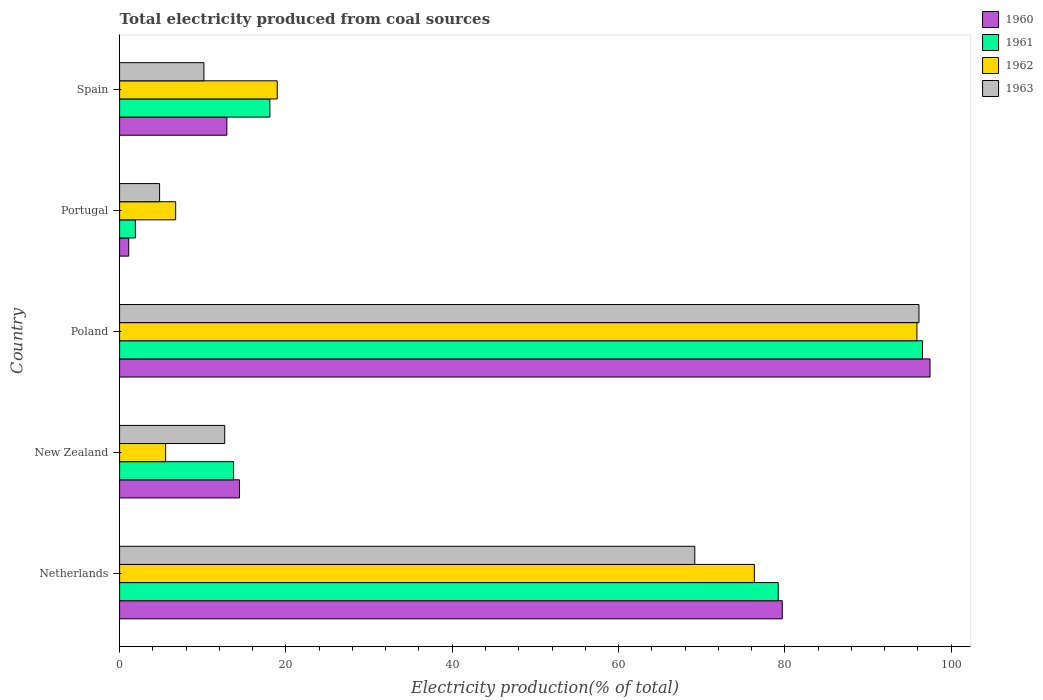How many different coloured bars are there?
Your response must be concise. 4. Are the number of bars per tick equal to the number of legend labels?
Provide a succinct answer. Yes. How many bars are there on the 5th tick from the bottom?
Provide a succinct answer. 4. What is the label of the 5th group of bars from the top?
Offer a terse response. Netherlands. What is the total electricity produced in 1963 in Poland?
Ensure brevity in your answer.  96.13. Across all countries, what is the maximum total electricity produced in 1961?
Your response must be concise. 96.56. Across all countries, what is the minimum total electricity produced in 1960?
Make the answer very short. 1.1. In which country was the total electricity produced in 1961 minimum?
Give a very brief answer. Portugal. What is the total total electricity produced in 1963 in the graph?
Offer a very short reply. 192.89. What is the difference between the total electricity produced in 1960 in Netherlands and that in Portugal?
Your answer should be compact. 78.59. What is the difference between the total electricity produced in 1960 in Portugal and the total electricity produced in 1961 in Spain?
Your answer should be compact. -16.97. What is the average total electricity produced in 1960 per country?
Provide a succinct answer. 41.11. What is the difference between the total electricity produced in 1963 and total electricity produced in 1960 in Poland?
Provide a succinct answer. -1.33. What is the ratio of the total electricity produced in 1961 in Portugal to that in Spain?
Offer a very short reply. 0.1. Is the total electricity produced in 1960 in Netherlands less than that in Spain?
Offer a very short reply. No. What is the difference between the highest and the second highest total electricity produced in 1961?
Your answer should be compact. 17.35. What is the difference between the highest and the lowest total electricity produced in 1960?
Provide a succinct answer. 96.36. What does the 2nd bar from the top in Portugal represents?
Make the answer very short. 1962. What does the 4th bar from the bottom in Spain represents?
Provide a short and direct response. 1963. Are all the bars in the graph horizontal?
Offer a terse response. Yes. How many countries are there in the graph?
Offer a terse response. 5. Does the graph contain grids?
Give a very brief answer. No. How many legend labels are there?
Keep it short and to the point. 4. How are the legend labels stacked?
Offer a terse response. Vertical. What is the title of the graph?
Provide a short and direct response. Total electricity produced from coal sources. What is the label or title of the X-axis?
Ensure brevity in your answer.  Electricity production(% of total). What is the Electricity production(% of total) of 1960 in Netherlands?
Give a very brief answer. 79.69. What is the Electricity production(% of total) of 1961 in Netherlands?
Ensure brevity in your answer.  79.2. What is the Electricity production(% of total) in 1962 in Netherlands?
Offer a very short reply. 76.33. What is the Electricity production(% of total) of 1963 in Netherlands?
Your answer should be very brief. 69.17. What is the Electricity production(% of total) in 1960 in New Zealand?
Give a very brief answer. 14.42. What is the Electricity production(% of total) in 1961 in New Zealand?
Provide a short and direct response. 13.71. What is the Electricity production(% of total) of 1962 in New Zealand?
Make the answer very short. 5.54. What is the Electricity production(% of total) in 1963 in New Zealand?
Provide a short and direct response. 12.64. What is the Electricity production(% of total) in 1960 in Poland?
Your response must be concise. 97.46. What is the Electricity production(% of total) in 1961 in Poland?
Make the answer very short. 96.56. What is the Electricity production(% of total) in 1962 in Poland?
Provide a short and direct response. 95.89. What is the Electricity production(% of total) in 1963 in Poland?
Keep it short and to the point. 96.13. What is the Electricity production(% of total) of 1960 in Portugal?
Offer a very short reply. 1.1. What is the Electricity production(% of total) of 1961 in Portugal?
Your answer should be compact. 1.89. What is the Electricity production(% of total) in 1962 in Portugal?
Make the answer very short. 6.74. What is the Electricity production(% of total) in 1963 in Portugal?
Your answer should be compact. 4.81. What is the Electricity production(% of total) in 1960 in Spain?
Ensure brevity in your answer.  12.9. What is the Electricity production(% of total) in 1961 in Spain?
Your response must be concise. 18.07. What is the Electricity production(% of total) in 1962 in Spain?
Offer a terse response. 18.96. What is the Electricity production(% of total) of 1963 in Spain?
Offer a terse response. 10.14. Across all countries, what is the maximum Electricity production(% of total) of 1960?
Give a very brief answer. 97.46. Across all countries, what is the maximum Electricity production(% of total) in 1961?
Make the answer very short. 96.56. Across all countries, what is the maximum Electricity production(% of total) in 1962?
Give a very brief answer. 95.89. Across all countries, what is the maximum Electricity production(% of total) in 1963?
Keep it short and to the point. 96.13. Across all countries, what is the minimum Electricity production(% of total) in 1960?
Make the answer very short. 1.1. Across all countries, what is the minimum Electricity production(% of total) in 1961?
Make the answer very short. 1.89. Across all countries, what is the minimum Electricity production(% of total) of 1962?
Your response must be concise. 5.54. Across all countries, what is the minimum Electricity production(% of total) of 1963?
Provide a short and direct response. 4.81. What is the total Electricity production(% of total) of 1960 in the graph?
Keep it short and to the point. 205.57. What is the total Electricity production(% of total) of 1961 in the graph?
Provide a succinct answer. 209.44. What is the total Electricity production(% of total) of 1962 in the graph?
Give a very brief answer. 203.46. What is the total Electricity production(% of total) of 1963 in the graph?
Ensure brevity in your answer.  192.89. What is the difference between the Electricity production(% of total) in 1960 in Netherlands and that in New Zealand?
Offer a terse response. 65.28. What is the difference between the Electricity production(% of total) of 1961 in Netherlands and that in New Zealand?
Offer a very short reply. 65.5. What is the difference between the Electricity production(% of total) of 1962 in Netherlands and that in New Zealand?
Provide a short and direct response. 70.8. What is the difference between the Electricity production(% of total) in 1963 in Netherlands and that in New Zealand?
Offer a very short reply. 56.53. What is the difference between the Electricity production(% of total) of 1960 in Netherlands and that in Poland?
Make the answer very short. -17.77. What is the difference between the Electricity production(% of total) of 1961 in Netherlands and that in Poland?
Your response must be concise. -17.35. What is the difference between the Electricity production(% of total) in 1962 in Netherlands and that in Poland?
Give a very brief answer. -19.56. What is the difference between the Electricity production(% of total) in 1963 in Netherlands and that in Poland?
Your response must be concise. -26.96. What is the difference between the Electricity production(% of total) of 1960 in Netherlands and that in Portugal?
Keep it short and to the point. 78.59. What is the difference between the Electricity production(% of total) in 1961 in Netherlands and that in Portugal?
Give a very brief answer. 77.31. What is the difference between the Electricity production(% of total) in 1962 in Netherlands and that in Portugal?
Give a very brief answer. 69.59. What is the difference between the Electricity production(% of total) in 1963 in Netherlands and that in Portugal?
Offer a very short reply. 64.36. What is the difference between the Electricity production(% of total) in 1960 in Netherlands and that in Spain?
Give a very brief answer. 66.79. What is the difference between the Electricity production(% of total) of 1961 in Netherlands and that in Spain?
Provide a succinct answer. 61.13. What is the difference between the Electricity production(% of total) in 1962 in Netherlands and that in Spain?
Your answer should be very brief. 57.38. What is the difference between the Electricity production(% of total) of 1963 in Netherlands and that in Spain?
Keep it short and to the point. 59.04. What is the difference between the Electricity production(% of total) in 1960 in New Zealand and that in Poland?
Provide a short and direct response. -83.05. What is the difference between the Electricity production(% of total) of 1961 in New Zealand and that in Poland?
Make the answer very short. -82.85. What is the difference between the Electricity production(% of total) of 1962 in New Zealand and that in Poland?
Ensure brevity in your answer.  -90.35. What is the difference between the Electricity production(% of total) of 1963 in New Zealand and that in Poland?
Offer a very short reply. -83.49. What is the difference between the Electricity production(% of total) of 1960 in New Zealand and that in Portugal?
Provide a short and direct response. 13.32. What is the difference between the Electricity production(% of total) of 1961 in New Zealand and that in Portugal?
Your answer should be very brief. 11.81. What is the difference between the Electricity production(% of total) in 1962 in New Zealand and that in Portugal?
Give a very brief answer. -1.2. What is the difference between the Electricity production(% of total) in 1963 in New Zealand and that in Portugal?
Ensure brevity in your answer.  7.83. What is the difference between the Electricity production(% of total) of 1960 in New Zealand and that in Spain?
Make the answer very short. 1.52. What is the difference between the Electricity production(% of total) of 1961 in New Zealand and that in Spain?
Offer a terse response. -4.36. What is the difference between the Electricity production(% of total) of 1962 in New Zealand and that in Spain?
Provide a succinct answer. -13.42. What is the difference between the Electricity production(% of total) of 1963 in New Zealand and that in Spain?
Your answer should be compact. 2.5. What is the difference between the Electricity production(% of total) in 1960 in Poland and that in Portugal?
Keep it short and to the point. 96.36. What is the difference between the Electricity production(% of total) in 1961 in Poland and that in Portugal?
Keep it short and to the point. 94.66. What is the difference between the Electricity production(% of total) of 1962 in Poland and that in Portugal?
Ensure brevity in your answer.  89.15. What is the difference between the Electricity production(% of total) in 1963 in Poland and that in Portugal?
Your response must be concise. 91.32. What is the difference between the Electricity production(% of total) of 1960 in Poland and that in Spain?
Give a very brief answer. 84.56. What is the difference between the Electricity production(% of total) in 1961 in Poland and that in Spain?
Give a very brief answer. 78.49. What is the difference between the Electricity production(% of total) in 1962 in Poland and that in Spain?
Offer a very short reply. 76.93. What is the difference between the Electricity production(% of total) in 1963 in Poland and that in Spain?
Your answer should be compact. 86. What is the difference between the Electricity production(% of total) of 1960 in Portugal and that in Spain?
Provide a succinct answer. -11.8. What is the difference between the Electricity production(% of total) of 1961 in Portugal and that in Spain?
Your answer should be very brief. -16.18. What is the difference between the Electricity production(% of total) of 1962 in Portugal and that in Spain?
Offer a very short reply. -12.22. What is the difference between the Electricity production(% of total) in 1963 in Portugal and that in Spain?
Provide a short and direct response. -5.33. What is the difference between the Electricity production(% of total) in 1960 in Netherlands and the Electricity production(% of total) in 1961 in New Zealand?
Your answer should be very brief. 65.98. What is the difference between the Electricity production(% of total) of 1960 in Netherlands and the Electricity production(% of total) of 1962 in New Zealand?
Offer a very short reply. 74.16. What is the difference between the Electricity production(% of total) of 1960 in Netherlands and the Electricity production(% of total) of 1963 in New Zealand?
Provide a succinct answer. 67.05. What is the difference between the Electricity production(% of total) in 1961 in Netherlands and the Electricity production(% of total) in 1962 in New Zealand?
Make the answer very short. 73.67. What is the difference between the Electricity production(% of total) of 1961 in Netherlands and the Electricity production(% of total) of 1963 in New Zealand?
Your answer should be very brief. 66.56. What is the difference between the Electricity production(% of total) of 1962 in Netherlands and the Electricity production(% of total) of 1963 in New Zealand?
Offer a very short reply. 63.69. What is the difference between the Electricity production(% of total) in 1960 in Netherlands and the Electricity production(% of total) in 1961 in Poland?
Provide a succinct answer. -16.86. What is the difference between the Electricity production(% of total) in 1960 in Netherlands and the Electricity production(% of total) in 1962 in Poland?
Offer a very short reply. -16.2. What is the difference between the Electricity production(% of total) in 1960 in Netherlands and the Electricity production(% of total) in 1963 in Poland?
Give a very brief answer. -16.44. What is the difference between the Electricity production(% of total) in 1961 in Netherlands and the Electricity production(% of total) in 1962 in Poland?
Offer a very short reply. -16.68. What is the difference between the Electricity production(% of total) of 1961 in Netherlands and the Electricity production(% of total) of 1963 in Poland?
Your answer should be very brief. -16.93. What is the difference between the Electricity production(% of total) in 1962 in Netherlands and the Electricity production(% of total) in 1963 in Poland?
Ensure brevity in your answer.  -19.8. What is the difference between the Electricity production(% of total) of 1960 in Netherlands and the Electricity production(% of total) of 1961 in Portugal?
Offer a terse response. 77.8. What is the difference between the Electricity production(% of total) in 1960 in Netherlands and the Electricity production(% of total) in 1962 in Portugal?
Ensure brevity in your answer.  72.95. What is the difference between the Electricity production(% of total) in 1960 in Netherlands and the Electricity production(% of total) in 1963 in Portugal?
Make the answer very short. 74.88. What is the difference between the Electricity production(% of total) of 1961 in Netherlands and the Electricity production(% of total) of 1962 in Portugal?
Provide a succinct answer. 72.46. What is the difference between the Electricity production(% of total) in 1961 in Netherlands and the Electricity production(% of total) in 1963 in Portugal?
Your response must be concise. 74.4. What is the difference between the Electricity production(% of total) of 1962 in Netherlands and the Electricity production(% of total) of 1963 in Portugal?
Your answer should be compact. 71.52. What is the difference between the Electricity production(% of total) in 1960 in Netherlands and the Electricity production(% of total) in 1961 in Spain?
Provide a short and direct response. 61.62. What is the difference between the Electricity production(% of total) in 1960 in Netherlands and the Electricity production(% of total) in 1962 in Spain?
Provide a short and direct response. 60.74. What is the difference between the Electricity production(% of total) in 1960 in Netherlands and the Electricity production(% of total) in 1963 in Spain?
Your answer should be compact. 69.56. What is the difference between the Electricity production(% of total) in 1961 in Netherlands and the Electricity production(% of total) in 1962 in Spain?
Offer a very short reply. 60.25. What is the difference between the Electricity production(% of total) of 1961 in Netherlands and the Electricity production(% of total) of 1963 in Spain?
Your answer should be compact. 69.07. What is the difference between the Electricity production(% of total) in 1962 in Netherlands and the Electricity production(% of total) in 1963 in Spain?
Make the answer very short. 66.2. What is the difference between the Electricity production(% of total) of 1960 in New Zealand and the Electricity production(% of total) of 1961 in Poland?
Keep it short and to the point. -82.14. What is the difference between the Electricity production(% of total) in 1960 in New Zealand and the Electricity production(% of total) in 1962 in Poland?
Make the answer very short. -81.47. What is the difference between the Electricity production(% of total) of 1960 in New Zealand and the Electricity production(% of total) of 1963 in Poland?
Your answer should be very brief. -81.71. What is the difference between the Electricity production(% of total) in 1961 in New Zealand and the Electricity production(% of total) in 1962 in Poland?
Give a very brief answer. -82.18. What is the difference between the Electricity production(% of total) in 1961 in New Zealand and the Electricity production(% of total) in 1963 in Poland?
Offer a terse response. -82.42. What is the difference between the Electricity production(% of total) of 1962 in New Zealand and the Electricity production(% of total) of 1963 in Poland?
Provide a succinct answer. -90.6. What is the difference between the Electricity production(% of total) in 1960 in New Zealand and the Electricity production(% of total) in 1961 in Portugal?
Give a very brief answer. 12.52. What is the difference between the Electricity production(% of total) in 1960 in New Zealand and the Electricity production(% of total) in 1962 in Portugal?
Offer a terse response. 7.68. What is the difference between the Electricity production(% of total) of 1960 in New Zealand and the Electricity production(% of total) of 1963 in Portugal?
Give a very brief answer. 9.61. What is the difference between the Electricity production(% of total) in 1961 in New Zealand and the Electricity production(% of total) in 1962 in Portugal?
Your response must be concise. 6.97. What is the difference between the Electricity production(% of total) in 1961 in New Zealand and the Electricity production(% of total) in 1963 in Portugal?
Give a very brief answer. 8.9. What is the difference between the Electricity production(% of total) of 1962 in New Zealand and the Electricity production(% of total) of 1963 in Portugal?
Your response must be concise. 0.73. What is the difference between the Electricity production(% of total) in 1960 in New Zealand and the Electricity production(% of total) in 1961 in Spain?
Offer a very short reply. -3.65. What is the difference between the Electricity production(% of total) of 1960 in New Zealand and the Electricity production(% of total) of 1962 in Spain?
Ensure brevity in your answer.  -4.54. What is the difference between the Electricity production(% of total) of 1960 in New Zealand and the Electricity production(% of total) of 1963 in Spain?
Offer a terse response. 4.28. What is the difference between the Electricity production(% of total) in 1961 in New Zealand and the Electricity production(% of total) in 1962 in Spain?
Provide a succinct answer. -5.25. What is the difference between the Electricity production(% of total) of 1961 in New Zealand and the Electricity production(% of total) of 1963 in Spain?
Offer a terse response. 3.57. What is the difference between the Electricity production(% of total) in 1962 in New Zealand and the Electricity production(% of total) in 1963 in Spain?
Make the answer very short. -4.6. What is the difference between the Electricity production(% of total) in 1960 in Poland and the Electricity production(% of total) in 1961 in Portugal?
Offer a terse response. 95.57. What is the difference between the Electricity production(% of total) of 1960 in Poland and the Electricity production(% of total) of 1962 in Portugal?
Your answer should be very brief. 90.72. What is the difference between the Electricity production(% of total) in 1960 in Poland and the Electricity production(% of total) in 1963 in Portugal?
Your answer should be very brief. 92.65. What is the difference between the Electricity production(% of total) of 1961 in Poland and the Electricity production(% of total) of 1962 in Portugal?
Provide a succinct answer. 89.82. What is the difference between the Electricity production(% of total) in 1961 in Poland and the Electricity production(% of total) in 1963 in Portugal?
Offer a very short reply. 91.75. What is the difference between the Electricity production(% of total) of 1962 in Poland and the Electricity production(% of total) of 1963 in Portugal?
Your response must be concise. 91.08. What is the difference between the Electricity production(% of total) of 1960 in Poland and the Electricity production(% of total) of 1961 in Spain?
Keep it short and to the point. 79.39. What is the difference between the Electricity production(% of total) in 1960 in Poland and the Electricity production(% of total) in 1962 in Spain?
Offer a terse response. 78.51. What is the difference between the Electricity production(% of total) of 1960 in Poland and the Electricity production(% of total) of 1963 in Spain?
Your response must be concise. 87.33. What is the difference between the Electricity production(% of total) of 1961 in Poland and the Electricity production(% of total) of 1962 in Spain?
Give a very brief answer. 77.6. What is the difference between the Electricity production(% of total) of 1961 in Poland and the Electricity production(% of total) of 1963 in Spain?
Keep it short and to the point. 86.42. What is the difference between the Electricity production(% of total) in 1962 in Poland and the Electricity production(% of total) in 1963 in Spain?
Provide a succinct answer. 85.75. What is the difference between the Electricity production(% of total) of 1960 in Portugal and the Electricity production(% of total) of 1961 in Spain?
Offer a terse response. -16.97. What is the difference between the Electricity production(% of total) in 1960 in Portugal and the Electricity production(% of total) in 1962 in Spain?
Your answer should be very brief. -17.86. What is the difference between the Electricity production(% of total) in 1960 in Portugal and the Electricity production(% of total) in 1963 in Spain?
Give a very brief answer. -9.04. What is the difference between the Electricity production(% of total) of 1961 in Portugal and the Electricity production(% of total) of 1962 in Spain?
Give a very brief answer. -17.06. What is the difference between the Electricity production(% of total) of 1961 in Portugal and the Electricity production(% of total) of 1963 in Spain?
Make the answer very short. -8.24. What is the difference between the Electricity production(% of total) in 1962 in Portugal and the Electricity production(% of total) in 1963 in Spain?
Your answer should be very brief. -3.4. What is the average Electricity production(% of total) in 1960 per country?
Offer a very short reply. 41.11. What is the average Electricity production(% of total) in 1961 per country?
Your answer should be compact. 41.89. What is the average Electricity production(% of total) in 1962 per country?
Provide a succinct answer. 40.69. What is the average Electricity production(% of total) of 1963 per country?
Your answer should be compact. 38.58. What is the difference between the Electricity production(% of total) of 1960 and Electricity production(% of total) of 1961 in Netherlands?
Your response must be concise. 0.49. What is the difference between the Electricity production(% of total) in 1960 and Electricity production(% of total) in 1962 in Netherlands?
Provide a short and direct response. 3.36. What is the difference between the Electricity production(% of total) in 1960 and Electricity production(% of total) in 1963 in Netherlands?
Your answer should be very brief. 10.52. What is the difference between the Electricity production(% of total) in 1961 and Electricity production(% of total) in 1962 in Netherlands?
Offer a terse response. 2.87. What is the difference between the Electricity production(% of total) of 1961 and Electricity production(% of total) of 1963 in Netherlands?
Your answer should be compact. 10.03. What is the difference between the Electricity production(% of total) of 1962 and Electricity production(% of total) of 1963 in Netherlands?
Ensure brevity in your answer.  7.16. What is the difference between the Electricity production(% of total) of 1960 and Electricity production(% of total) of 1961 in New Zealand?
Keep it short and to the point. 0.71. What is the difference between the Electricity production(% of total) in 1960 and Electricity production(% of total) in 1962 in New Zealand?
Offer a very short reply. 8.88. What is the difference between the Electricity production(% of total) in 1960 and Electricity production(% of total) in 1963 in New Zealand?
Your answer should be very brief. 1.78. What is the difference between the Electricity production(% of total) of 1961 and Electricity production(% of total) of 1962 in New Zealand?
Keep it short and to the point. 8.17. What is the difference between the Electricity production(% of total) of 1961 and Electricity production(% of total) of 1963 in New Zealand?
Ensure brevity in your answer.  1.07. What is the difference between the Electricity production(% of total) of 1962 and Electricity production(% of total) of 1963 in New Zealand?
Make the answer very short. -7.1. What is the difference between the Electricity production(% of total) of 1960 and Electricity production(% of total) of 1961 in Poland?
Offer a terse response. 0.91. What is the difference between the Electricity production(% of total) in 1960 and Electricity production(% of total) in 1962 in Poland?
Provide a short and direct response. 1.57. What is the difference between the Electricity production(% of total) in 1960 and Electricity production(% of total) in 1963 in Poland?
Offer a terse response. 1.33. What is the difference between the Electricity production(% of total) of 1961 and Electricity production(% of total) of 1962 in Poland?
Keep it short and to the point. 0.67. What is the difference between the Electricity production(% of total) in 1961 and Electricity production(% of total) in 1963 in Poland?
Give a very brief answer. 0.43. What is the difference between the Electricity production(% of total) in 1962 and Electricity production(% of total) in 1963 in Poland?
Offer a terse response. -0.24. What is the difference between the Electricity production(% of total) of 1960 and Electricity production(% of total) of 1961 in Portugal?
Your answer should be compact. -0.8. What is the difference between the Electricity production(% of total) in 1960 and Electricity production(% of total) in 1962 in Portugal?
Make the answer very short. -5.64. What is the difference between the Electricity production(% of total) in 1960 and Electricity production(% of total) in 1963 in Portugal?
Provide a short and direct response. -3.71. What is the difference between the Electricity production(% of total) in 1961 and Electricity production(% of total) in 1962 in Portugal?
Your answer should be compact. -4.85. What is the difference between the Electricity production(% of total) of 1961 and Electricity production(% of total) of 1963 in Portugal?
Offer a terse response. -2.91. What is the difference between the Electricity production(% of total) of 1962 and Electricity production(% of total) of 1963 in Portugal?
Provide a short and direct response. 1.93. What is the difference between the Electricity production(% of total) in 1960 and Electricity production(% of total) in 1961 in Spain?
Give a very brief answer. -5.17. What is the difference between the Electricity production(% of total) of 1960 and Electricity production(% of total) of 1962 in Spain?
Provide a short and direct response. -6.06. What is the difference between the Electricity production(% of total) of 1960 and Electricity production(% of total) of 1963 in Spain?
Provide a short and direct response. 2.76. What is the difference between the Electricity production(% of total) of 1961 and Electricity production(% of total) of 1962 in Spain?
Keep it short and to the point. -0.88. What is the difference between the Electricity production(% of total) of 1961 and Electricity production(% of total) of 1963 in Spain?
Provide a succinct answer. 7.94. What is the difference between the Electricity production(% of total) in 1962 and Electricity production(% of total) in 1963 in Spain?
Keep it short and to the point. 8.82. What is the ratio of the Electricity production(% of total) in 1960 in Netherlands to that in New Zealand?
Provide a succinct answer. 5.53. What is the ratio of the Electricity production(% of total) in 1961 in Netherlands to that in New Zealand?
Provide a succinct answer. 5.78. What is the ratio of the Electricity production(% of total) of 1962 in Netherlands to that in New Zealand?
Ensure brevity in your answer.  13.79. What is the ratio of the Electricity production(% of total) of 1963 in Netherlands to that in New Zealand?
Give a very brief answer. 5.47. What is the ratio of the Electricity production(% of total) of 1960 in Netherlands to that in Poland?
Your answer should be compact. 0.82. What is the ratio of the Electricity production(% of total) of 1961 in Netherlands to that in Poland?
Offer a terse response. 0.82. What is the ratio of the Electricity production(% of total) of 1962 in Netherlands to that in Poland?
Your answer should be very brief. 0.8. What is the ratio of the Electricity production(% of total) in 1963 in Netherlands to that in Poland?
Your response must be concise. 0.72. What is the ratio of the Electricity production(% of total) of 1960 in Netherlands to that in Portugal?
Give a very brief answer. 72.59. What is the ratio of the Electricity production(% of total) in 1961 in Netherlands to that in Portugal?
Ensure brevity in your answer.  41.81. What is the ratio of the Electricity production(% of total) of 1962 in Netherlands to that in Portugal?
Provide a short and direct response. 11.32. What is the ratio of the Electricity production(% of total) of 1963 in Netherlands to that in Portugal?
Provide a short and direct response. 14.38. What is the ratio of the Electricity production(% of total) of 1960 in Netherlands to that in Spain?
Offer a terse response. 6.18. What is the ratio of the Electricity production(% of total) of 1961 in Netherlands to that in Spain?
Your response must be concise. 4.38. What is the ratio of the Electricity production(% of total) of 1962 in Netherlands to that in Spain?
Your answer should be compact. 4.03. What is the ratio of the Electricity production(% of total) in 1963 in Netherlands to that in Spain?
Make the answer very short. 6.82. What is the ratio of the Electricity production(% of total) of 1960 in New Zealand to that in Poland?
Your answer should be compact. 0.15. What is the ratio of the Electricity production(% of total) in 1961 in New Zealand to that in Poland?
Make the answer very short. 0.14. What is the ratio of the Electricity production(% of total) of 1962 in New Zealand to that in Poland?
Your answer should be very brief. 0.06. What is the ratio of the Electricity production(% of total) of 1963 in New Zealand to that in Poland?
Provide a short and direct response. 0.13. What is the ratio of the Electricity production(% of total) of 1960 in New Zealand to that in Portugal?
Keep it short and to the point. 13.13. What is the ratio of the Electricity production(% of total) in 1961 in New Zealand to that in Portugal?
Keep it short and to the point. 7.24. What is the ratio of the Electricity production(% of total) of 1962 in New Zealand to that in Portugal?
Provide a short and direct response. 0.82. What is the ratio of the Electricity production(% of total) in 1963 in New Zealand to that in Portugal?
Your answer should be very brief. 2.63. What is the ratio of the Electricity production(% of total) in 1960 in New Zealand to that in Spain?
Your answer should be compact. 1.12. What is the ratio of the Electricity production(% of total) in 1961 in New Zealand to that in Spain?
Ensure brevity in your answer.  0.76. What is the ratio of the Electricity production(% of total) in 1962 in New Zealand to that in Spain?
Offer a very short reply. 0.29. What is the ratio of the Electricity production(% of total) in 1963 in New Zealand to that in Spain?
Keep it short and to the point. 1.25. What is the ratio of the Electricity production(% of total) in 1960 in Poland to that in Portugal?
Your response must be concise. 88.77. What is the ratio of the Electricity production(% of total) of 1961 in Poland to that in Portugal?
Ensure brevity in your answer.  50.97. What is the ratio of the Electricity production(% of total) in 1962 in Poland to that in Portugal?
Keep it short and to the point. 14.23. What is the ratio of the Electricity production(% of total) of 1963 in Poland to that in Portugal?
Make the answer very short. 19.99. What is the ratio of the Electricity production(% of total) of 1960 in Poland to that in Spain?
Your answer should be very brief. 7.56. What is the ratio of the Electricity production(% of total) of 1961 in Poland to that in Spain?
Provide a succinct answer. 5.34. What is the ratio of the Electricity production(% of total) of 1962 in Poland to that in Spain?
Ensure brevity in your answer.  5.06. What is the ratio of the Electricity production(% of total) in 1963 in Poland to that in Spain?
Your answer should be very brief. 9.48. What is the ratio of the Electricity production(% of total) in 1960 in Portugal to that in Spain?
Offer a very short reply. 0.09. What is the ratio of the Electricity production(% of total) in 1961 in Portugal to that in Spain?
Give a very brief answer. 0.1. What is the ratio of the Electricity production(% of total) in 1962 in Portugal to that in Spain?
Provide a succinct answer. 0.36. What is the ratio of the Electricity production(% of total) in 1963 in Portugal to that in Spain?
Provide a short and direct response. 0.47. What is the difference between the highest and the second highest Electricity production(% of total) in 1960?
Keep it short and to the point. 17.77. What is the difference between the highest and the second highest Electricity production(% of total) of 1961?
Provide a short and direct response. 17.35. What is the difference between the highest and the second highest Electricity production(% of total) in 1962?
Your response must be concise. 19.56. What is the difference between the highest and the second highest Electricity production(% of total) in 1963?
Your answer should be compact. 26.96. What is the difference between the highest and the lowest Electricity production(% of total) of 1960?
Your response must be concise. 96.36. What is the difference between the highest and the lowest Electricity production(% of total) in 1961?
Give a very brief answer. 94.66. What is the difference between the highest and the lowest Electricity production(% of total) of 1962?
Your response must be concise. 90.35. What is the difference between the highest and the lowest Electricity production(% of total) of 1963?
Make the answer very short. 91.32. 